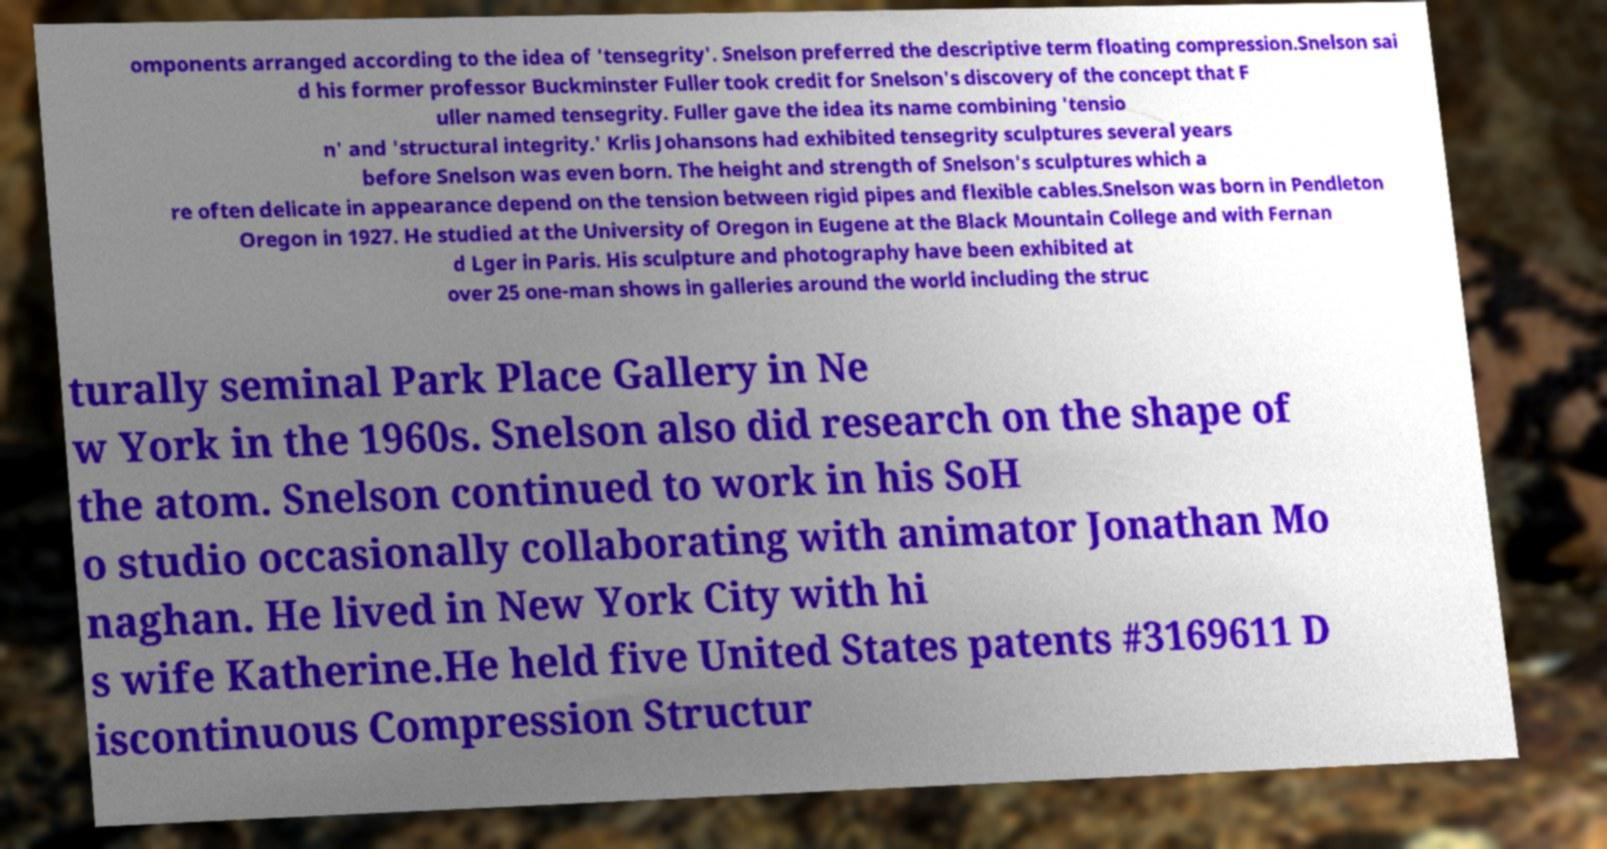Can you accurately transcribe the text from the provided image for me? omponents arranged according to the idea of 'tensegrity'. Snelson preferred the descriptive term floating compression.Snelson sai d his former professor Buckminster Fuller took credit for Snelson's discovery of the concept that F uller named tensegrity. Fuller gave the idea its name combining 'tensio n' and 'structural integrity.' Krlis Johansons had exhibited tensegrity sculptures several years before Snelson was even born. The height and strength of Snelson's sculptures which a re often delicate in appearance depend on the tension between rigid pipes and flexible cables.Snelson was born in Pendleton Oregon in 1927. He studied at the University of Oregon in Eugene at the Black Mountain College and with Fernan d Lger in Paris. His sculpture and photography have been exhibited at over 25 one-man shows in galleries around the world including the struc turally seminal Park Place Gallery in Ne w York in the 1960s. Snelson also did research on the shape of the atom. Snelson continued to work in his SoH o studio occasionally collaborating with animator Jonathan Mo naghan. He lived in New York City with hi s wife Katherine.He held five United States patents #3169611 D iscontinuous Compression Structur 